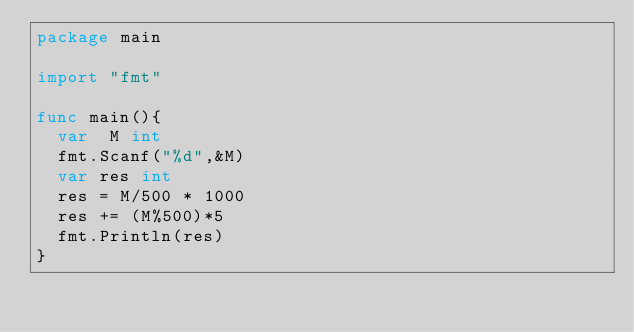<code> <loc_0><loc_0><loc_500><loc_500><_Go_>package main

import "fmt"

func main(){
	var  M int
	fmt.Scanf("%d",&M)
	var res int
	res = M/500 * 1000
	res += (M%500)*5
	fmt.Println(res)
}
</code> 